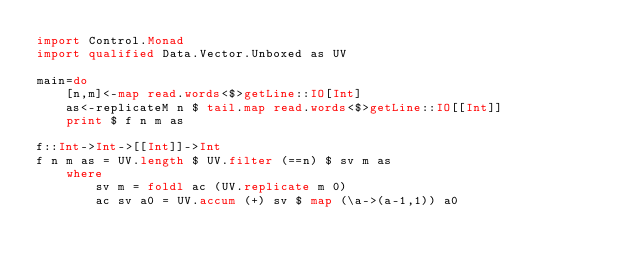Convert code to text. <code><loc_0><loc_0><loc_500><loc_500><_Haskell_>import Control.Monad
import qualified Data.Vector.Unboxed as UV

main=do
    [n,m]<-map read.words<$>getLine::IO[Int]
    as<-replicateM n $ tail.map read.words<$>getLine::IO[[Int]]
    print $ f n m as

f::Int->Int->[[Int]]->Int
f n m as = UV.length $ UV.filter (==n) $ sv m as
    where
        sv m = foldl ac (UV.replicate m 0)
        ac sv a0 = UV.accum (+) sv $ map (\a->(a-1,1)) a0
</code> 